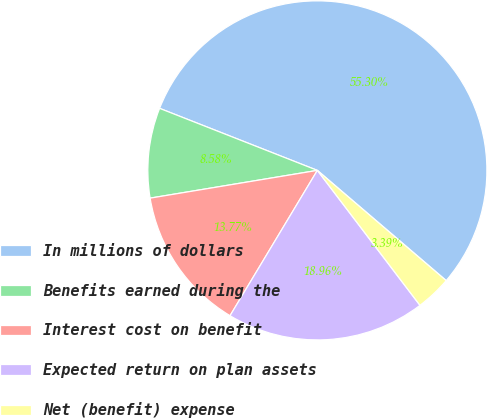<chart> <loc_0><loc_0><loc_500><loc_500><pie_chart><fcel>In millions of dollars<fcel>Benefits earned during the<fcel>Interest cost on benefit<fcel>Expected return on plan assets<fcel>Net (benefit) expense<nl><fcel>55.3%<fcel>8.58%<fcel>13.77%<fcel>18.96%<fcel>3.39%<nl></chart> 